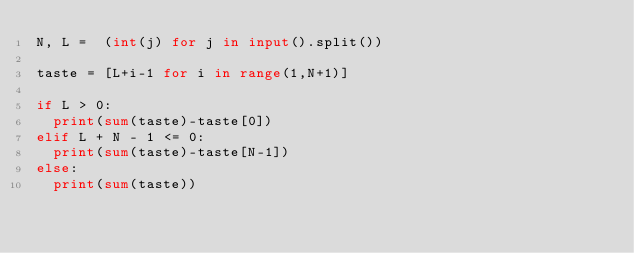Convert code to text. <code><loc_0><loc_0><loc_500><loc_500><_Python_>N, L =  (int(j) for j in input().split())  

taste = [L+i-1 for i in range(1,N+1)]

if L > 0:
  print(sum(taste)-taste[0])
elif L + N - 1 <= 0:
  print(sum(taste)-taste[N-1])
else:
  print(sum(taste))
</code> 